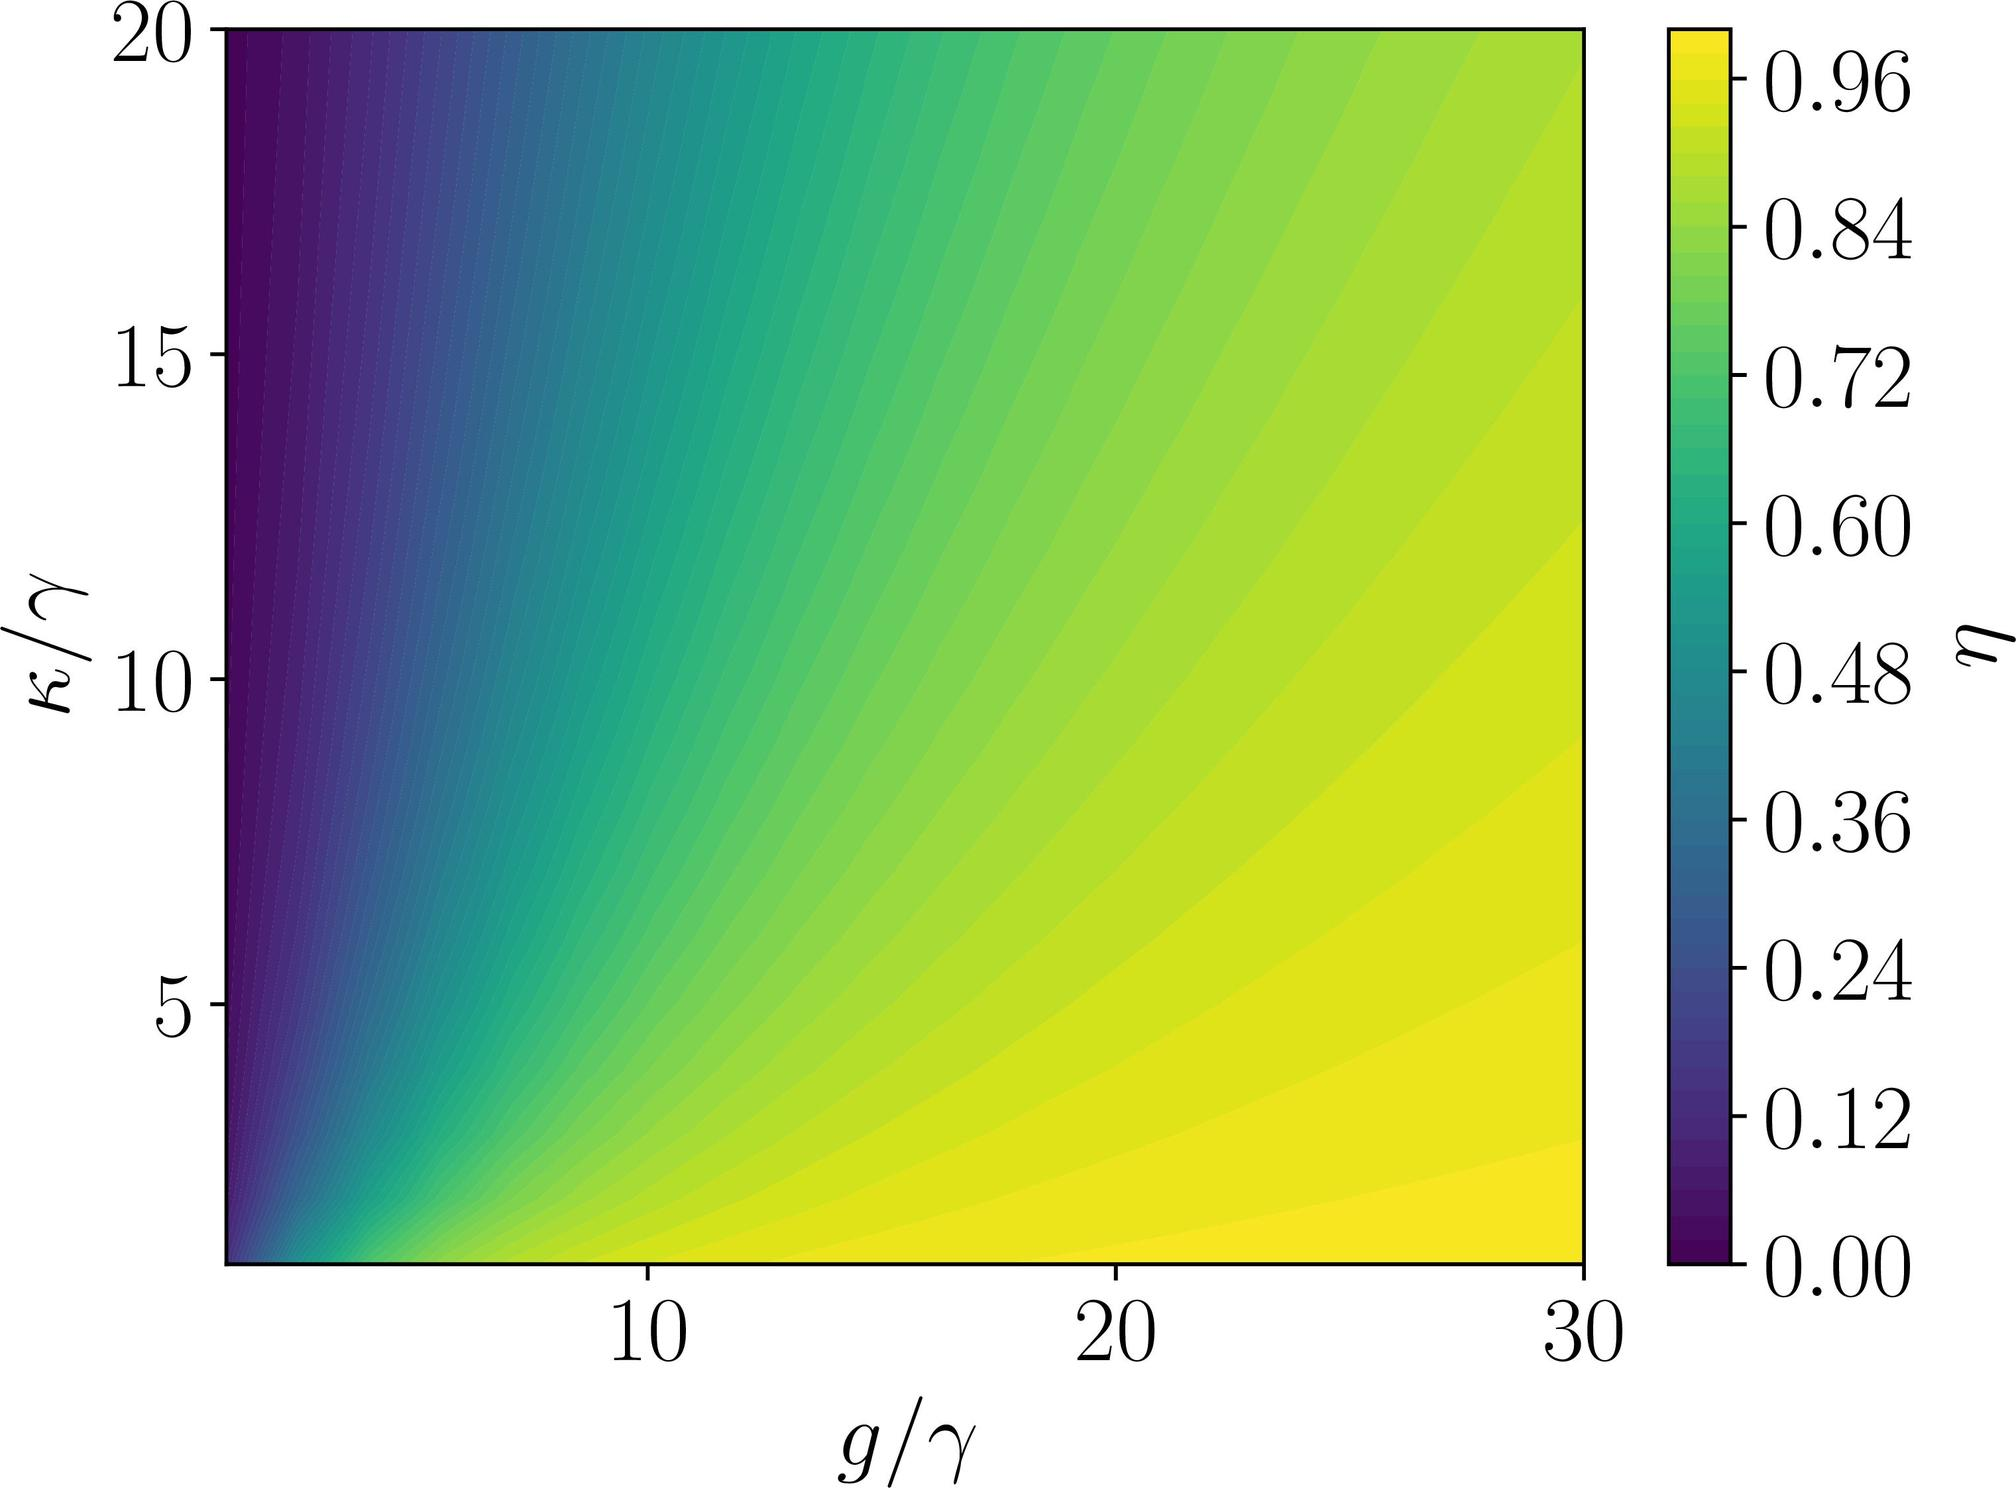What could the parameters g, γ, κ, and η potentially represent in a physical or mathematical context? These parameters are often symbolic and used in various scientific contexts. For instance, 'g' might stand for a coupling constant in physics, representing the strength of an interaction. Similarly, 'γ' could denote a damping coefficient or decay rate, and 'κ' might be a spring constant or some other form of rate constant. The variable 'η' typically symbolizes an efficiency or effectiveness metric in mathematical models. The specific physical interpretation would depend on the scientific or mathematical field from which this graph originates. 